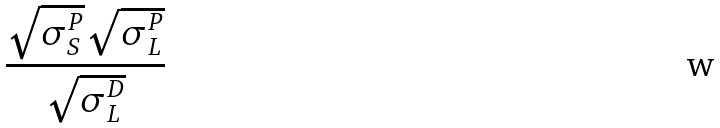Convert formula to latex. <formula><loc_0><loc_0><loc_500><loc_500>\frac { \sqrt { \sigma _ { S } ^ { P } } \sqrt { \sigma _ { L } ^ { P } } } { \sqrt { \sigma _ { L } ^ { D } } }</formula> 